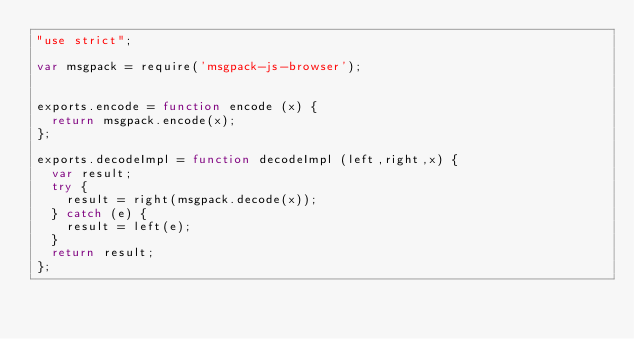Convert code to text. <code><loc_0><loc_0><loc_500><loc_500><_JavaScript_>"use strict";

var msgpack = require('msgpack-js-browser');


exports.encode = function encode (x) {
  return msgpack.encode(x);
};

exports.decodeImpl = function decodeImpl (left,right,x) {
  var result;
  try {
    result = right(msgpack.decode(x));
  } catch (e) {
    result = left(e);
  }
  return result;
};
</code> 